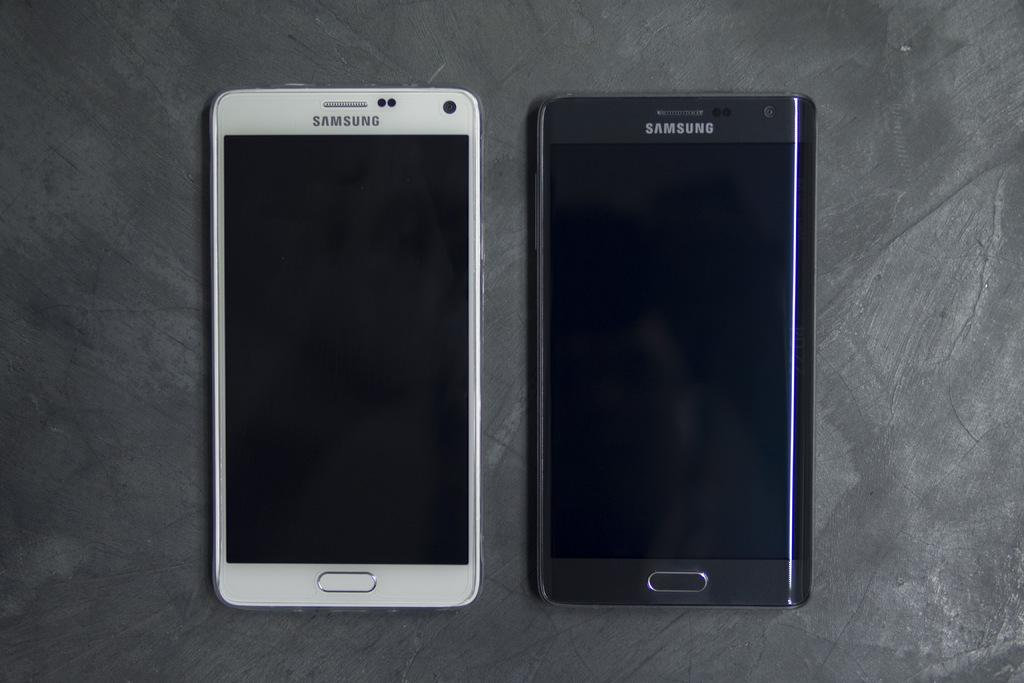<image>
Render a clear and concise summary of the photo. Two Samsung phones lay next to each other, one black and one white. 